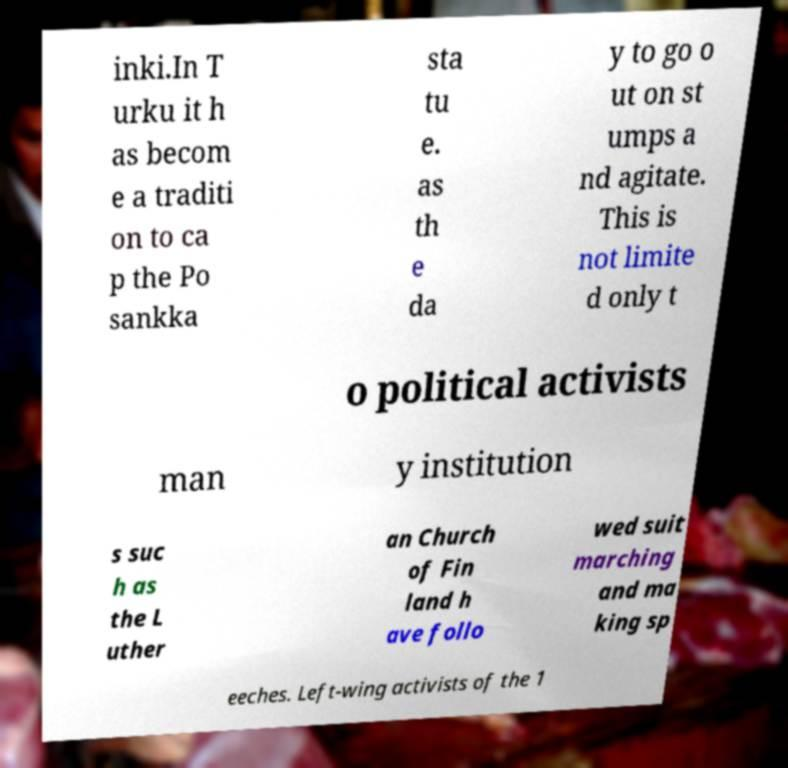Please identify and transcribe the text found in this image. inki.In T urku it h as becom e a traditi on to ca p the Po sankka sta tu e. as th e da y to go o ut on st umps a nd agitate. This is not limite d only t o political activists man y institution s suc h as the L uther an Church of Fin land h ave follo wed suit marching and ma king sp eeches. Left-wing activists of the 1 